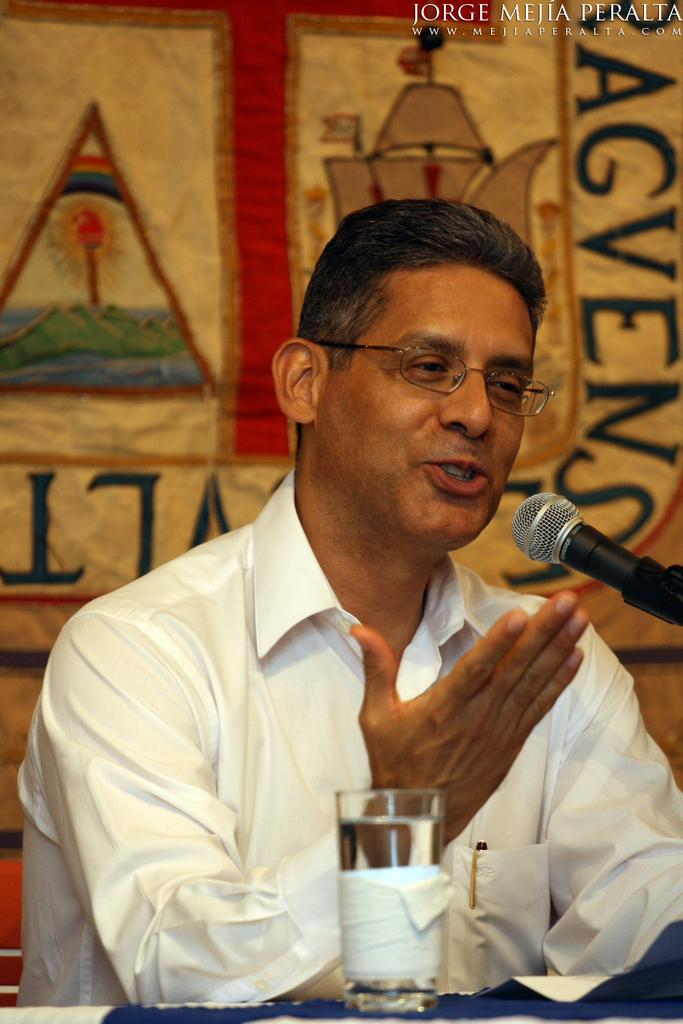What is the person in the image doing? There is a person talking in the image. What object might be used to amplify the person's voice? There is a microphone in the image. What type of container is visible in the image? There is a glass in the image. What can be seen in the background of the image? There is a banner in the background of the image. How does the person in the image burn bread? There is no bread present in the image, and the person is talking, not baking or preparing food. 